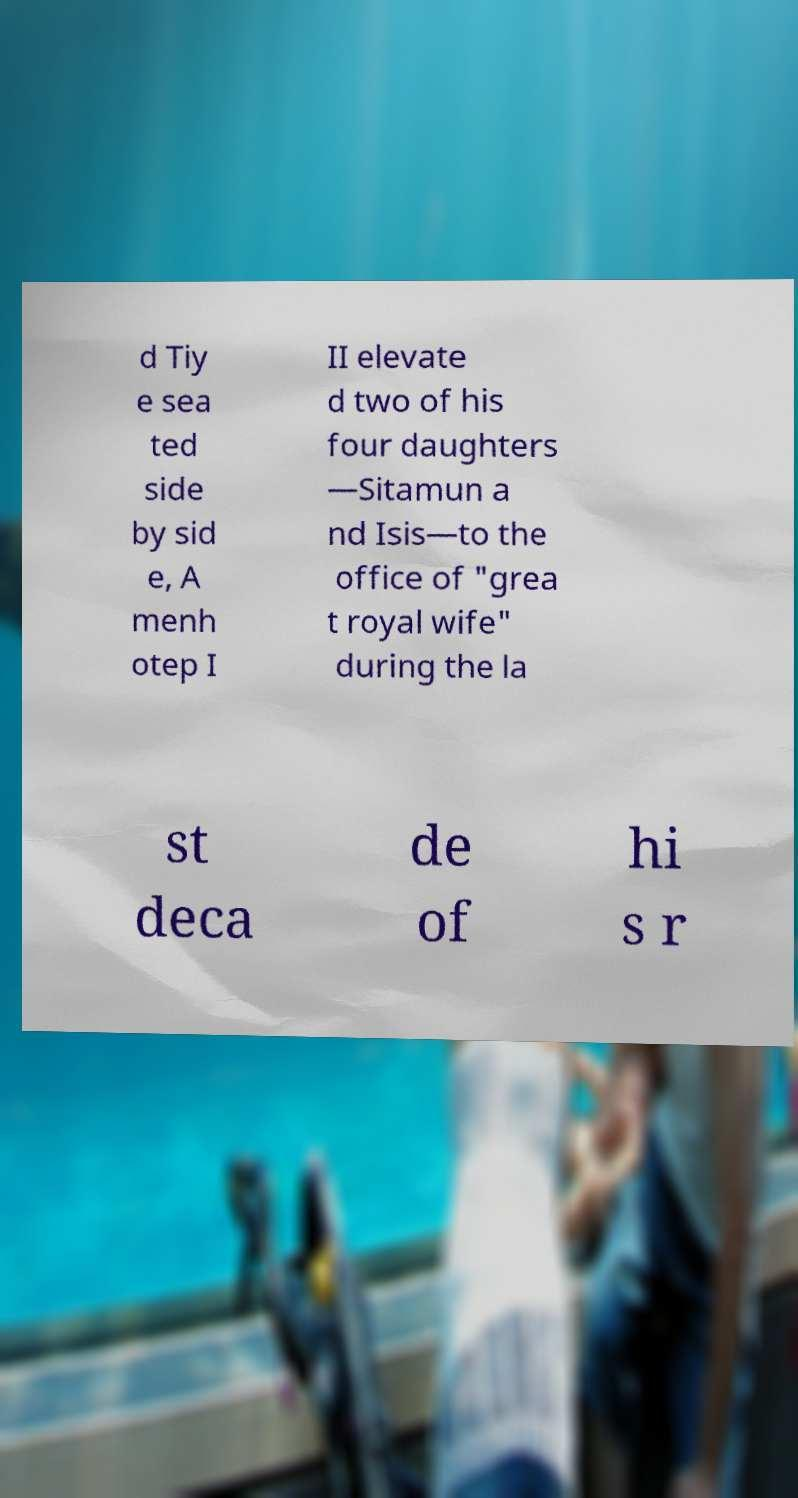There's text embedded in this image that I need extracted. Can you transcribe it verbatim? d Tiy e sea ted side by sid e, A menh otep I II elevate d two of his four daughters —Sitamun a nd Isis—to the office of "grea t royal wife" during the la st deca de of hi s r 